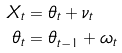<formula> <loc_0><loc_0><loc_500><loc_500>X _ { t } & = \theta _ { t } + \nu _ { t } \\ \theta _ { t } & = \theta _ { t - 1 } + \omega _ { t }</formula> 